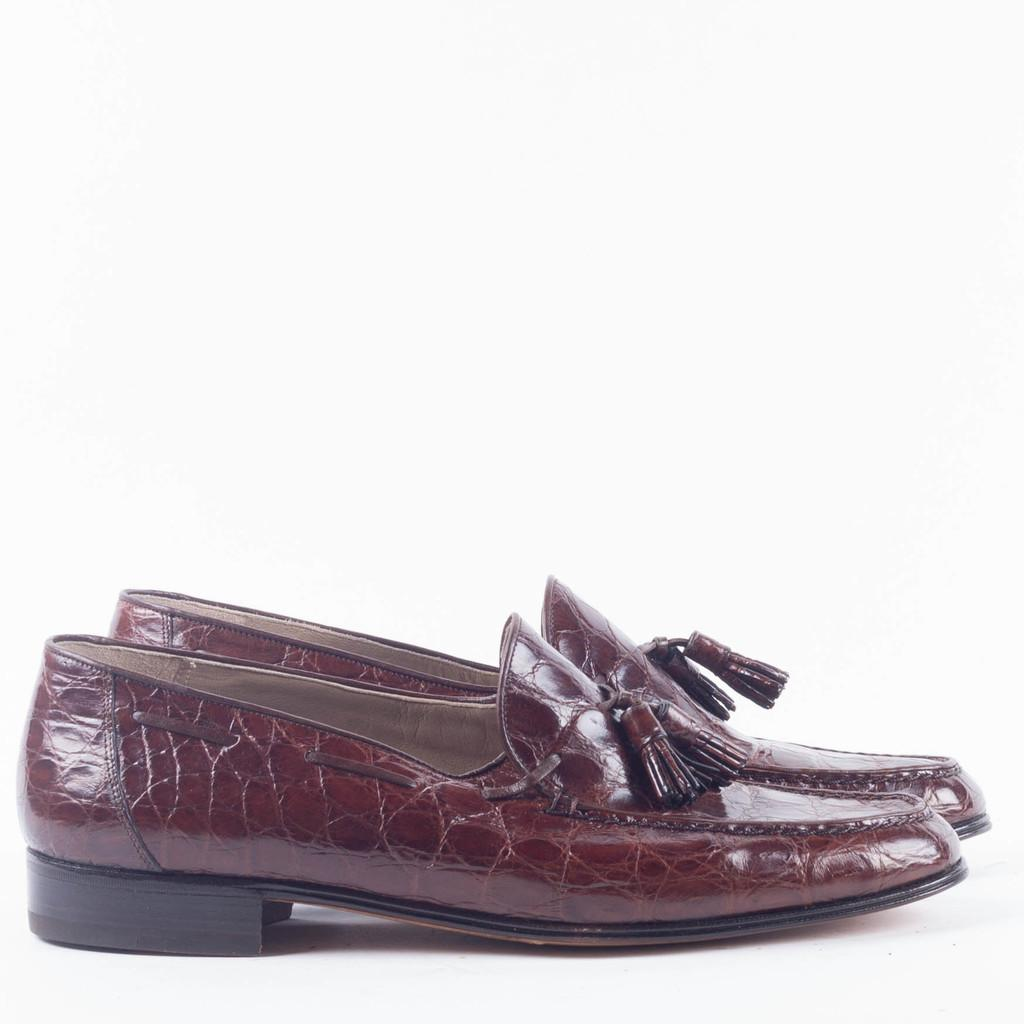What type of object is present in the image? There is a pair of shoes in the image. What type of insect can be seen crawling on the banana in the image? There is no banana or insect present in the image; it only features a pair of shoes. 